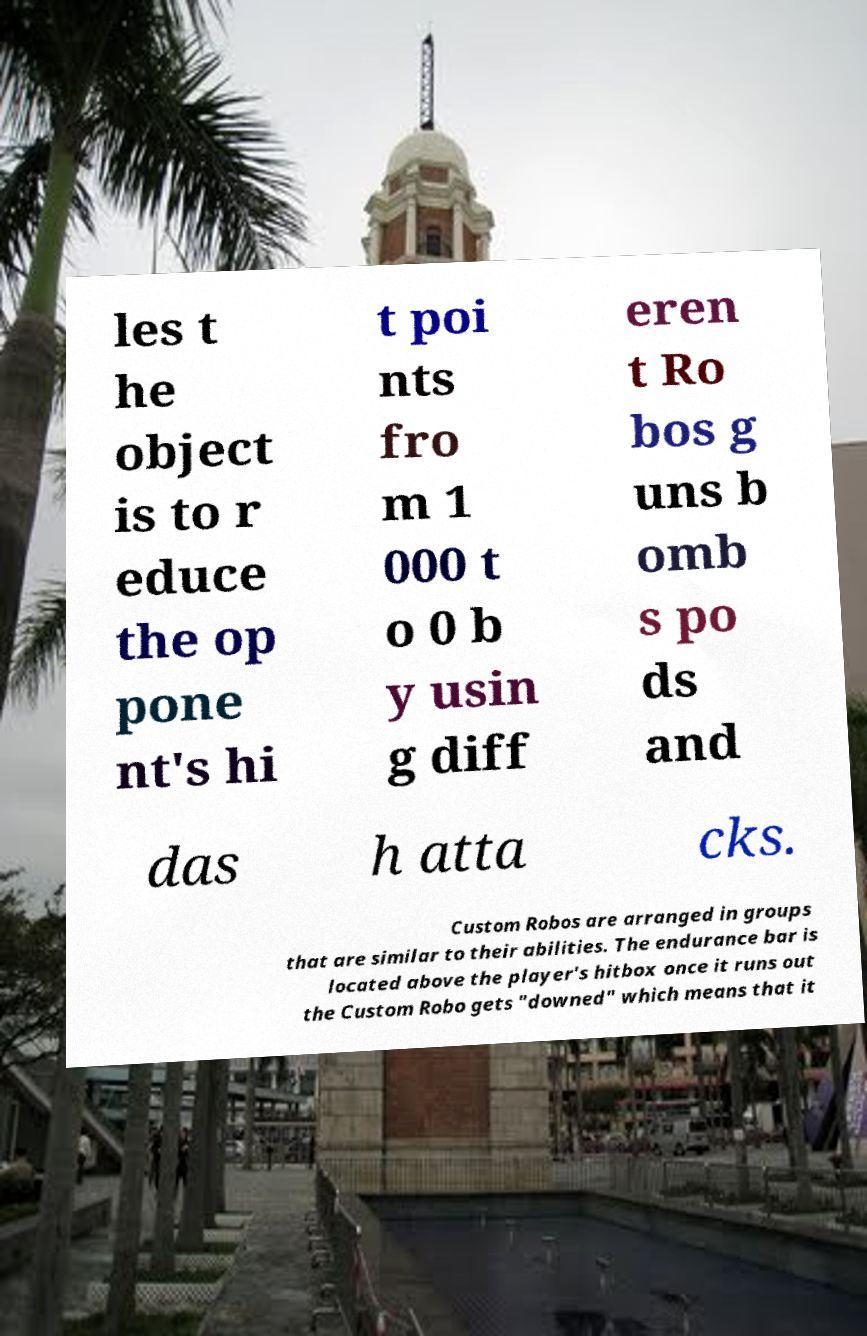Please identify and transcribe the text found in this image. les t he object is to r educe the op pone nt's hi t poi nts fro m 1 000 t o 0 b y usin g diff eren t Ro bos g uns b omb s po ds and das h atta cks. Custom Robos are arranged in groups that are similar to their abilities. The endurance bar is located above the player's hitbox once it runs out the Custom Robo gets "downed" which means that it 